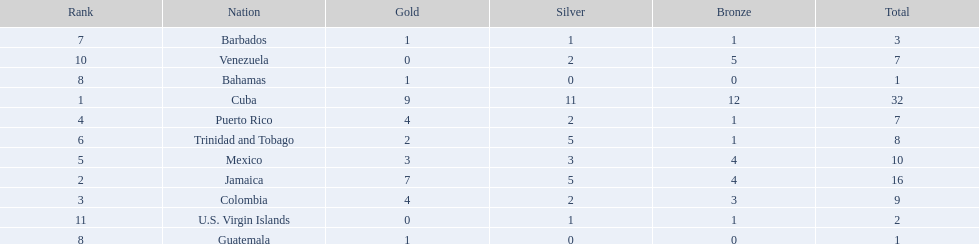What is the total number of gold medals awarded between these 11 countries? 32. 